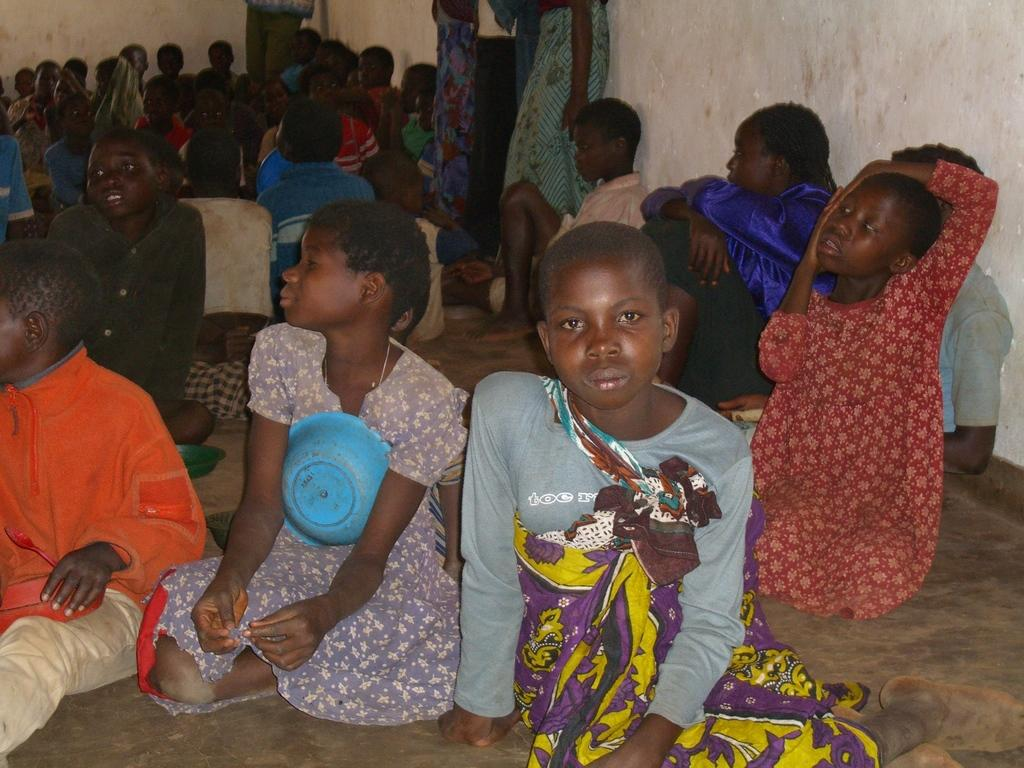What are the people in the image doing? There are people sitting on the floor and standing in the image. What can be seen in the background of the image? There is a wall in the background of the image. What type of chalk is being used to write the story on the wall in the image? There is no chalk or story written on the wall in the image. What selection of books can be seen on the floor in the image? There is no mention of books or a selection in the image. 